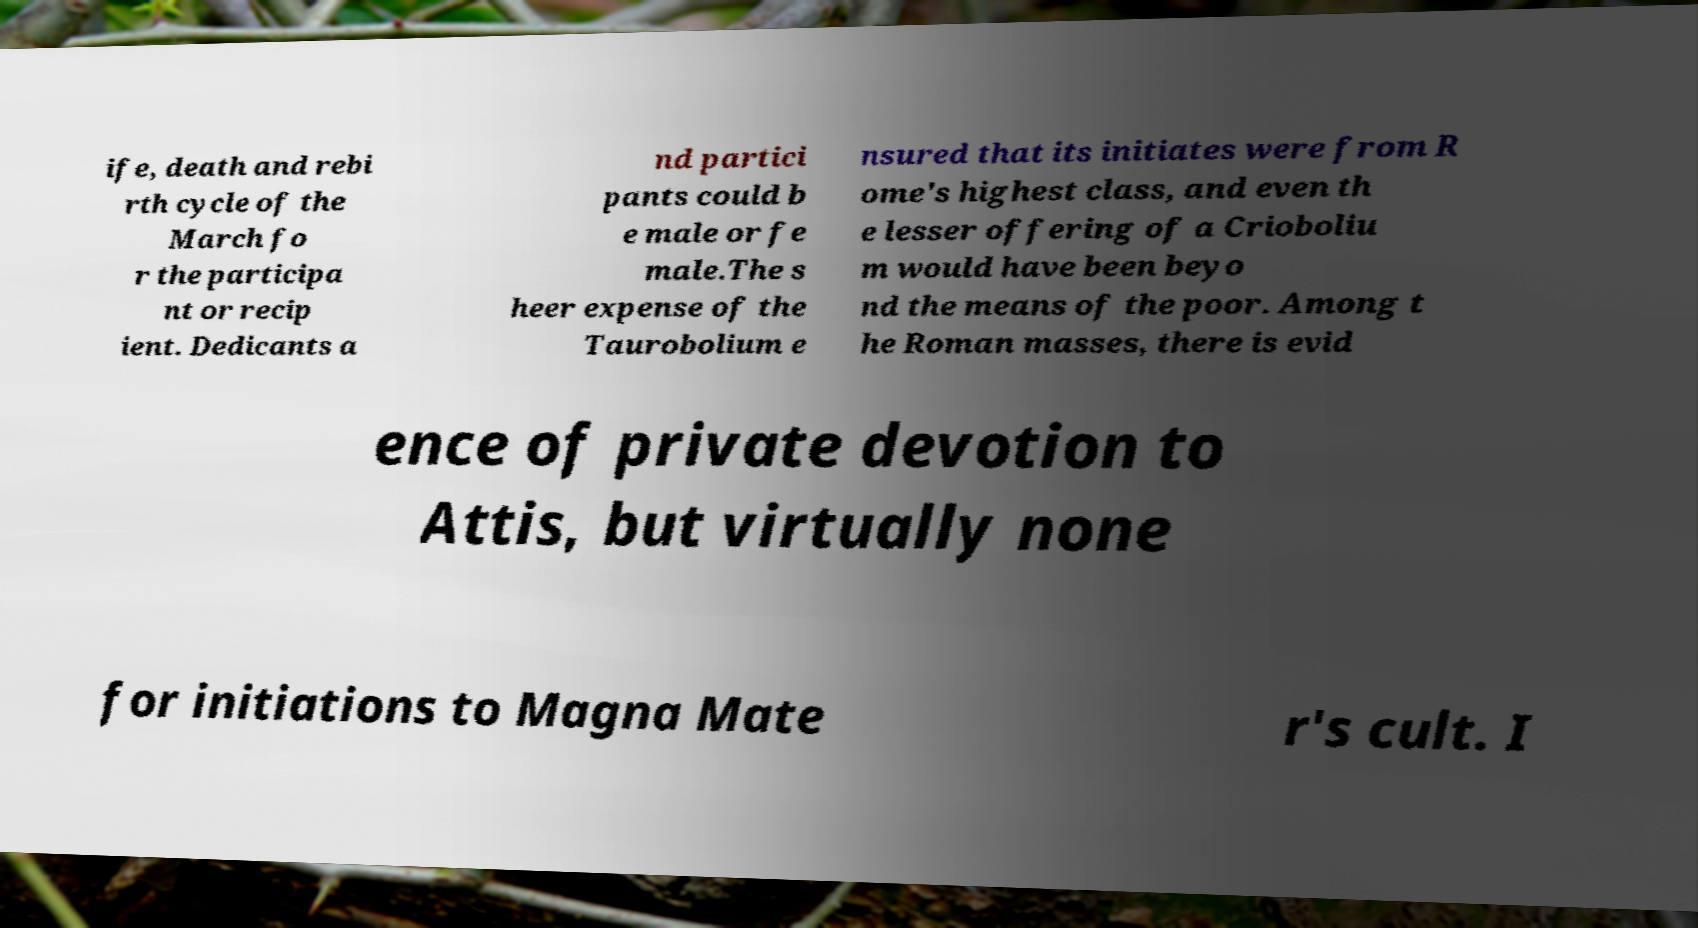Could you extract and type out the text from this image? ife, death and rebi rth cycle of the March fo r the participa nt or recip ient. Dedicants a nd partici pants could b e male or fe male.The s heer expense of the Taurobolium e nsured that its initiates were from R ome's highest class, and even th e lesser offering of a Crioboliu m would have been beyo nd the means of the poor. Among t he Roman masses, there is evid ence of private devotion to Attis, but virtually none for initiations to Magna Mate r's cult. I 